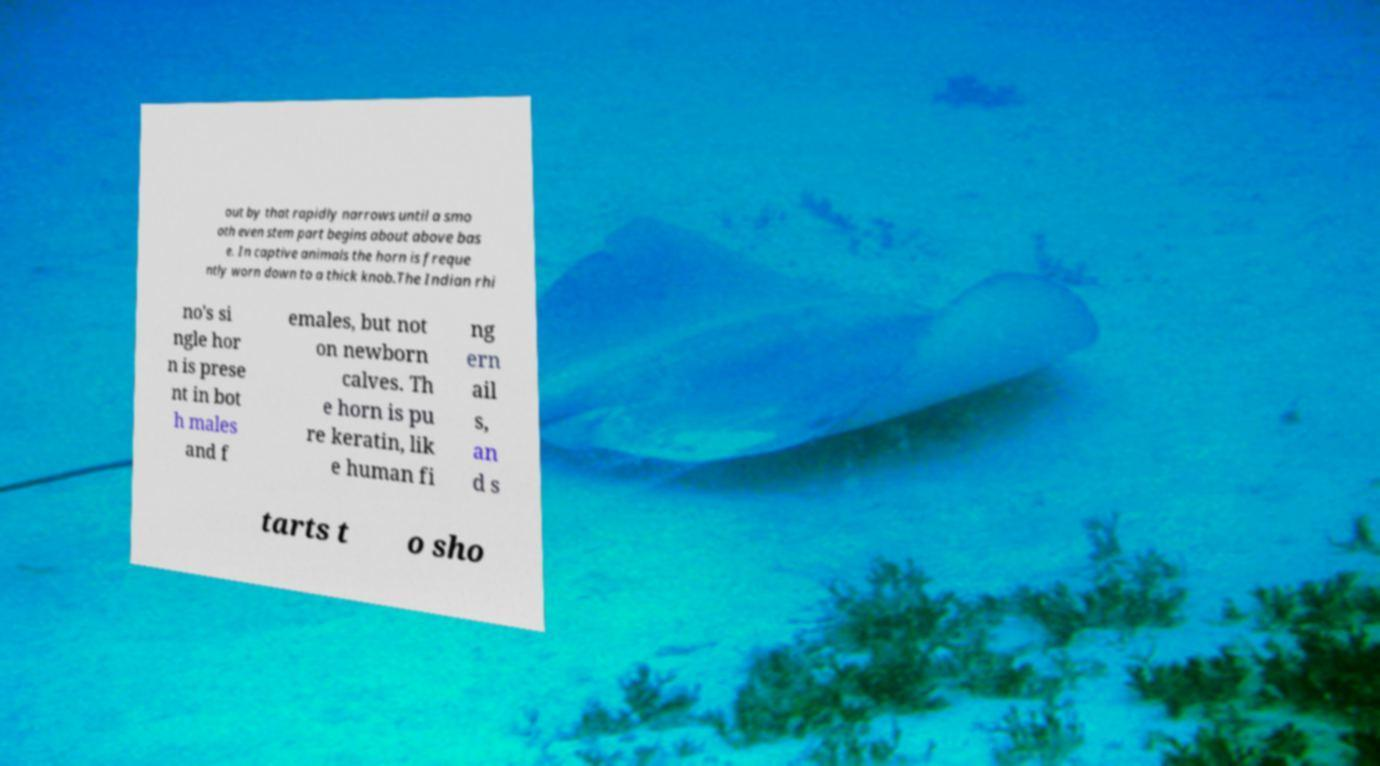Please read and relay the text visible in this image. What does it say? out by that rapidly narrows until a smo oth even stem part begins about above bas e. In captive animals the horn is freque ntly worn down to a thick knob.The Indian rhi no's si ngle hor n is prese nt in bot h males and f emales, but not on newborn calves. Th e horn is pu re keratin, lik e human fi ng ern ail s, an d s tarts t o sho 